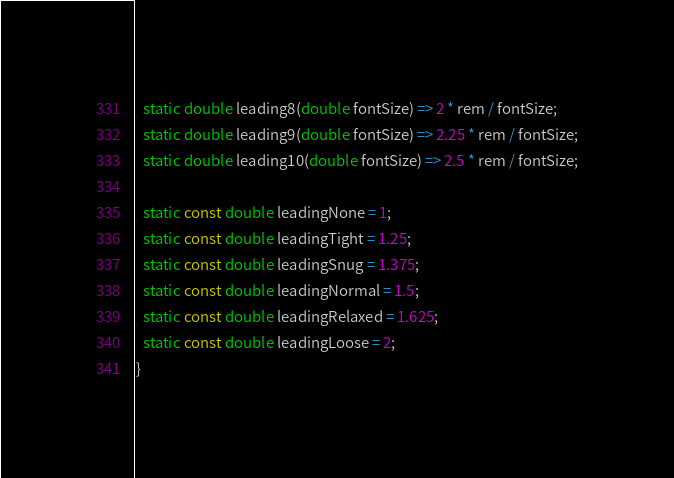<code> <loc_0><loc_0><loc_500><loc_500><_Dart_>  static double leading8(double fontSize) => 2 * rem / fontSize;
  static double leading9(double fontSize) => 2.25 * rem / fontSize;
  static double leading10(double fontSize) => 2.5 * rem / fontSize;

  static const double leadingNone = 1;
  static const double leadingTight = 1.25;
  static const double leadingSnug = 1.375;
  static const double leadingNormal = 1.5;
  static const double leadingRelaxed = 1.625;
  static const double leadingLoose = 2;
}
</code> 